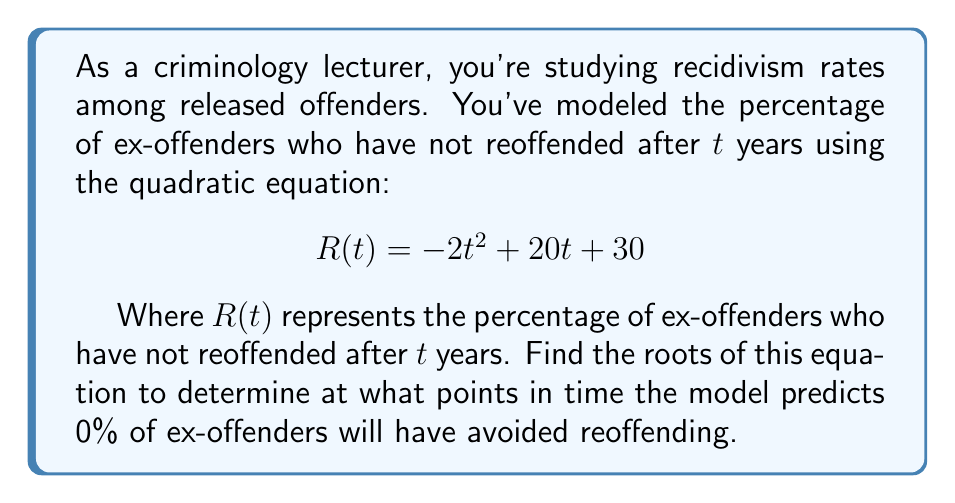Could you help me with this problem? To find the roots of the quadratic equation, we need to solve:

$$ -2t^2 + 20t + 30 = 0 $$

We can use the quadratic formula: $t = \frac{-b \pm \sqrt{b^2 - 4ac}}{2a}$

Where $a = -2$, $b = 20$, and $c = 30$

Step 1: Calculate the discriminant
$$ b^2 - 4ac = 20^2 - 4(-2)(30) = 400 + 240 = 640 $$

Step 2: Apply the quadratic formula
$$ t = \frac{-20 \pm \sqrt{640}}{2(-2)} $$

Step 3: Simplify
$$ t = \frac{-20 \pm 8\sqrt{10}}{-4} $$

Step 4: Separate the two solutions
$$ t_1 = \frac{-20 + 8\sqrt{10}}{-4} = 5 - 2\sqrt{10} $$
$$ t_2 = \frac{-20 - 8\sqrt{10}}{-4} = 5 + 2\sqrt{10} $$

These roots represent the time (in years) when the model predicts 0% of ex-offenders will have avoided reoffending.
Answer: The roots of the equation are $t_1 = 5 - 2\sqrt{10}$ years and $t_2 = 5 + 2\sqrt{10}$ years. 